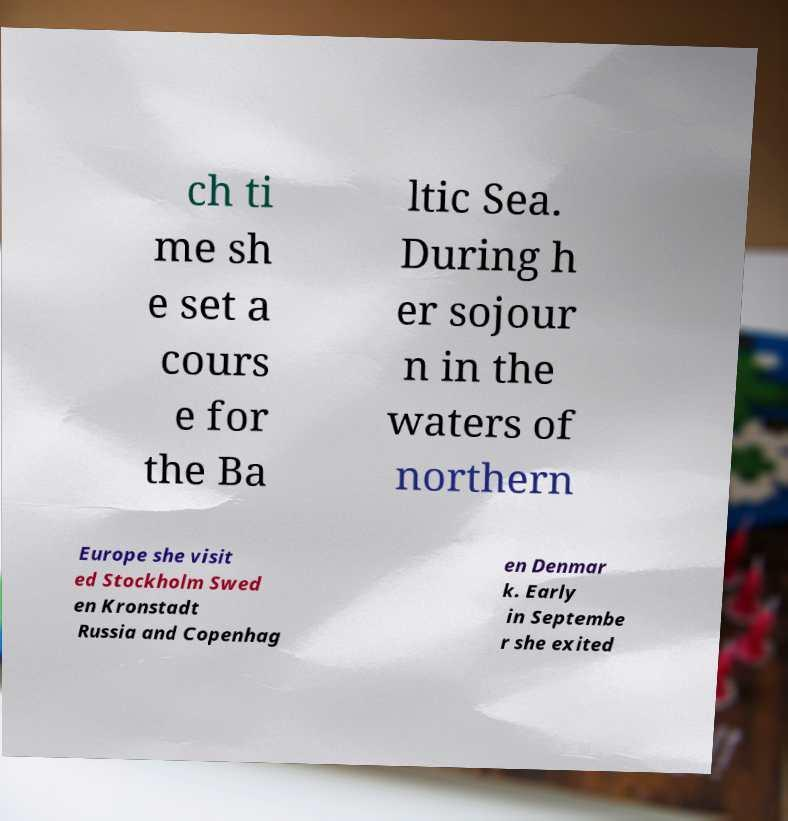Please identify and transcribe the text found in this image. ch ti me sh e set a cours e for the Ba ltic Sea. During h er sojour n in the waters of northern Europe she visit ed Stockholm Swed en Kronstadt Russia and Copenhag en Denmar k. Early in Septembe r she exited 